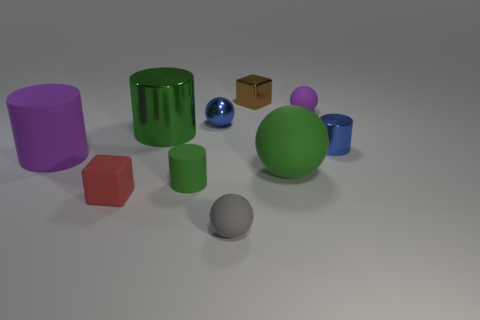Subtract all red spheres. Subtract all green blocks. How many spheres are left? 4 Subtract all balls. How many objects are left? 6 Add 7 small blue metallic balls. How many small blue metallic balls exist? 8 Subtract 1 green cylinders. How many objects are left? 9 Subtract all red objects. Subtract all gray balls. How many objects are left? 8 Add 8 large green cylinders. How many large green cylinders are left? 9 